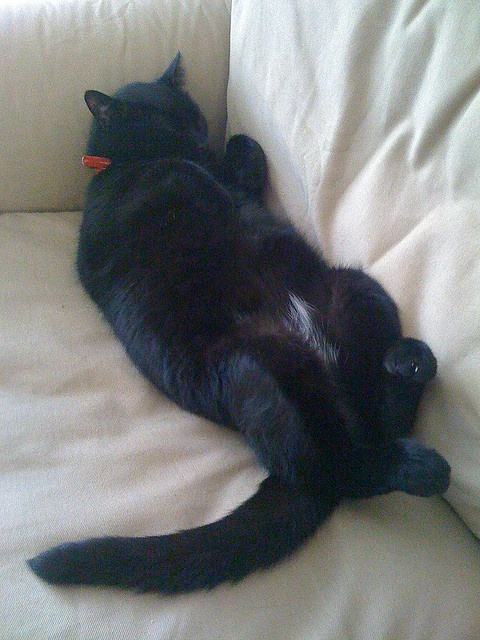Describe the objects in this image and their specific colors. I can see couch in white, darkgray, lightgray, and gray tones and cat in white, black, navy, gray, and blue tones in this image. 